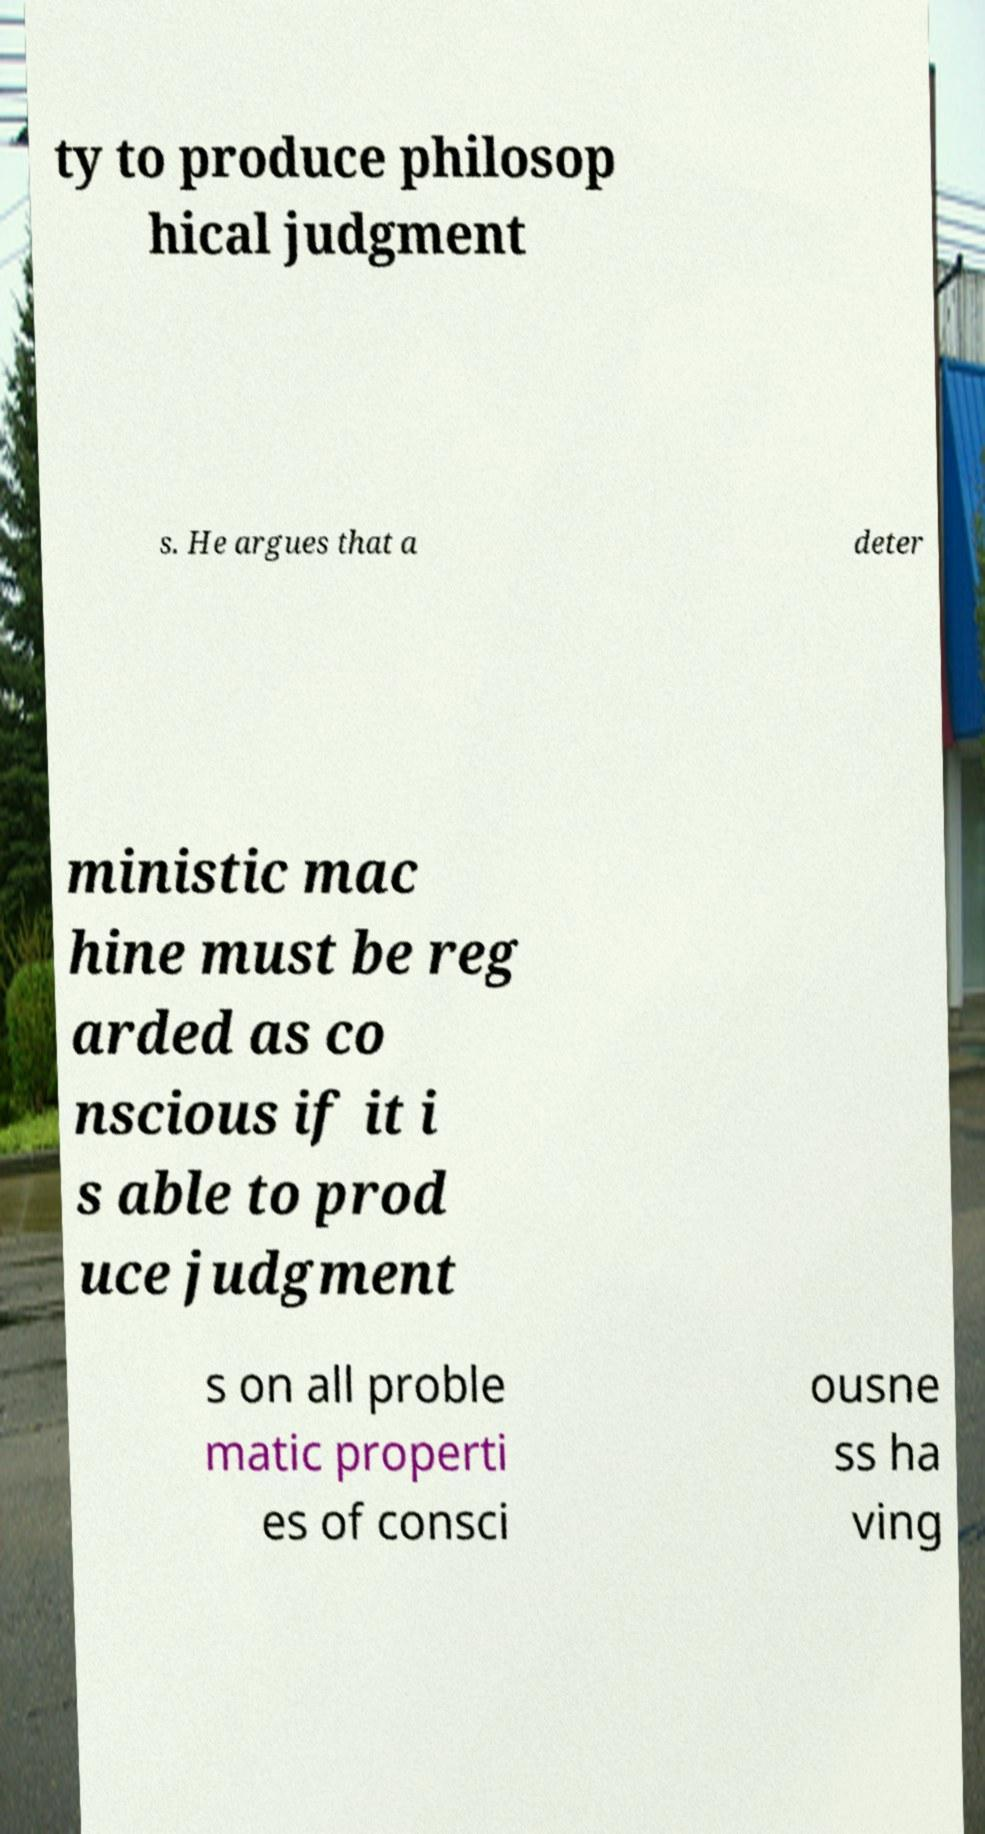What messages or text are displayed in this image? I need them in a readable, typed format. ty to produce philosop hical judgment s. He argues that a deter ministic mac hine must be reg arded as co nscious if it i s able to prod uce judgment s on all proble matic properti es of consci ousne ss ha ving 